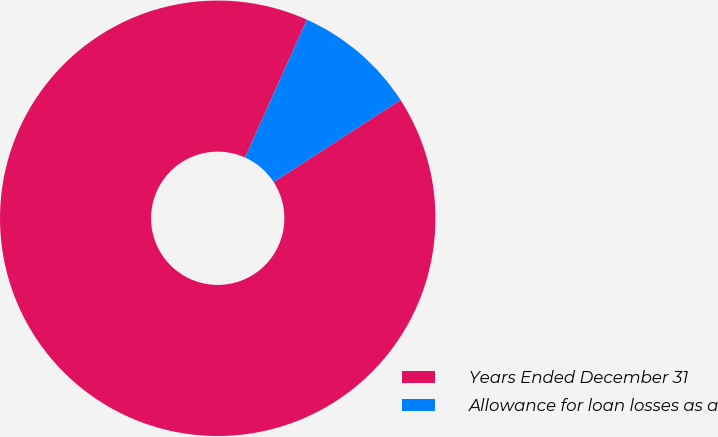<chart> <loc_0><loc_0><loc_500><loc_500><pie_chart><fcel>Years Ended December 31<fcel>Allowance for loan losses as a<nl><fcel>90.86%<fcel>9.14%<nl></chart> 